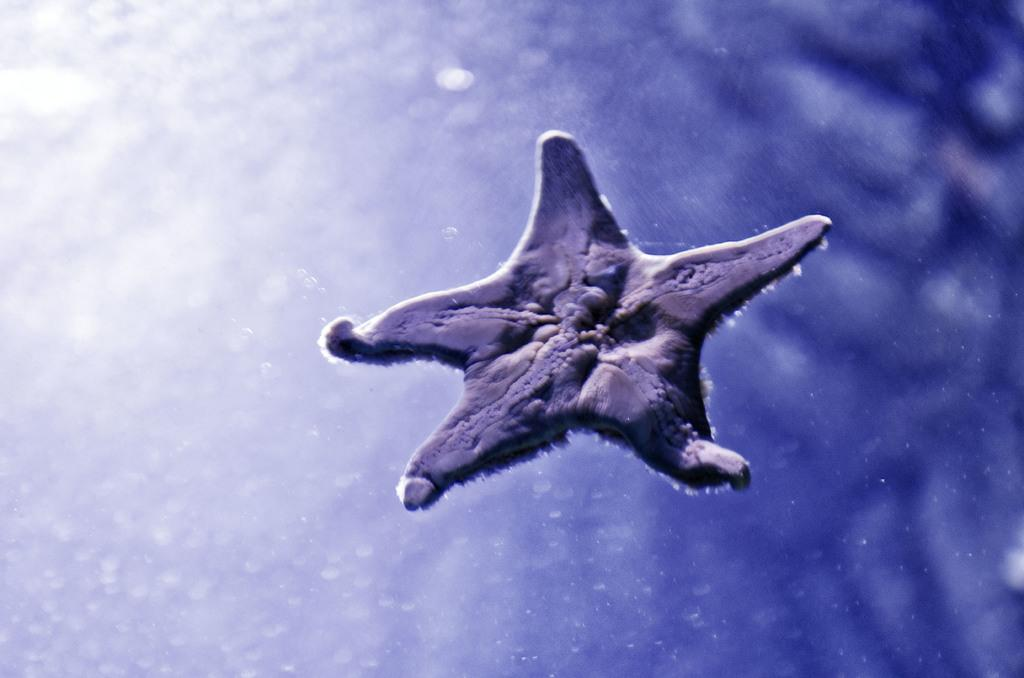What is the main subject of the image? There is a starfish in the image. Can you describe the background of the image? The background of the image is blurred. How many bats are flying in the image? There are no bats present in the image; it features a starfish. What unit of measurement is used to determine the size of the starfish in the image? The provided facts do not mention any specific unit of measurement for the starfish's size. 